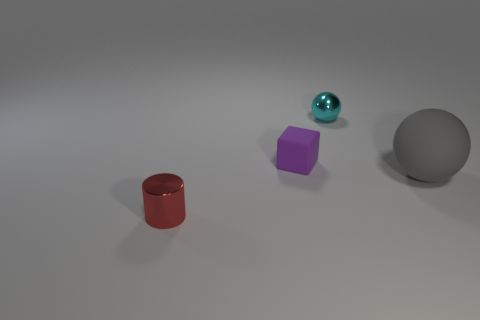Add 3 brown spheres. How many objects exist? 7 Subtract all cylinders. How many objects are left? 3 Add 3 blocks. How many blocks are left? 4 Add 1 purple rubber cylinders. How many purple rubber cylinders exist? 1 Subtract 0 cyan cylinders. How many objects are left? 4 Subtract all cyan balls. Subtract all small cyan spheres. How many objects are left? 2 